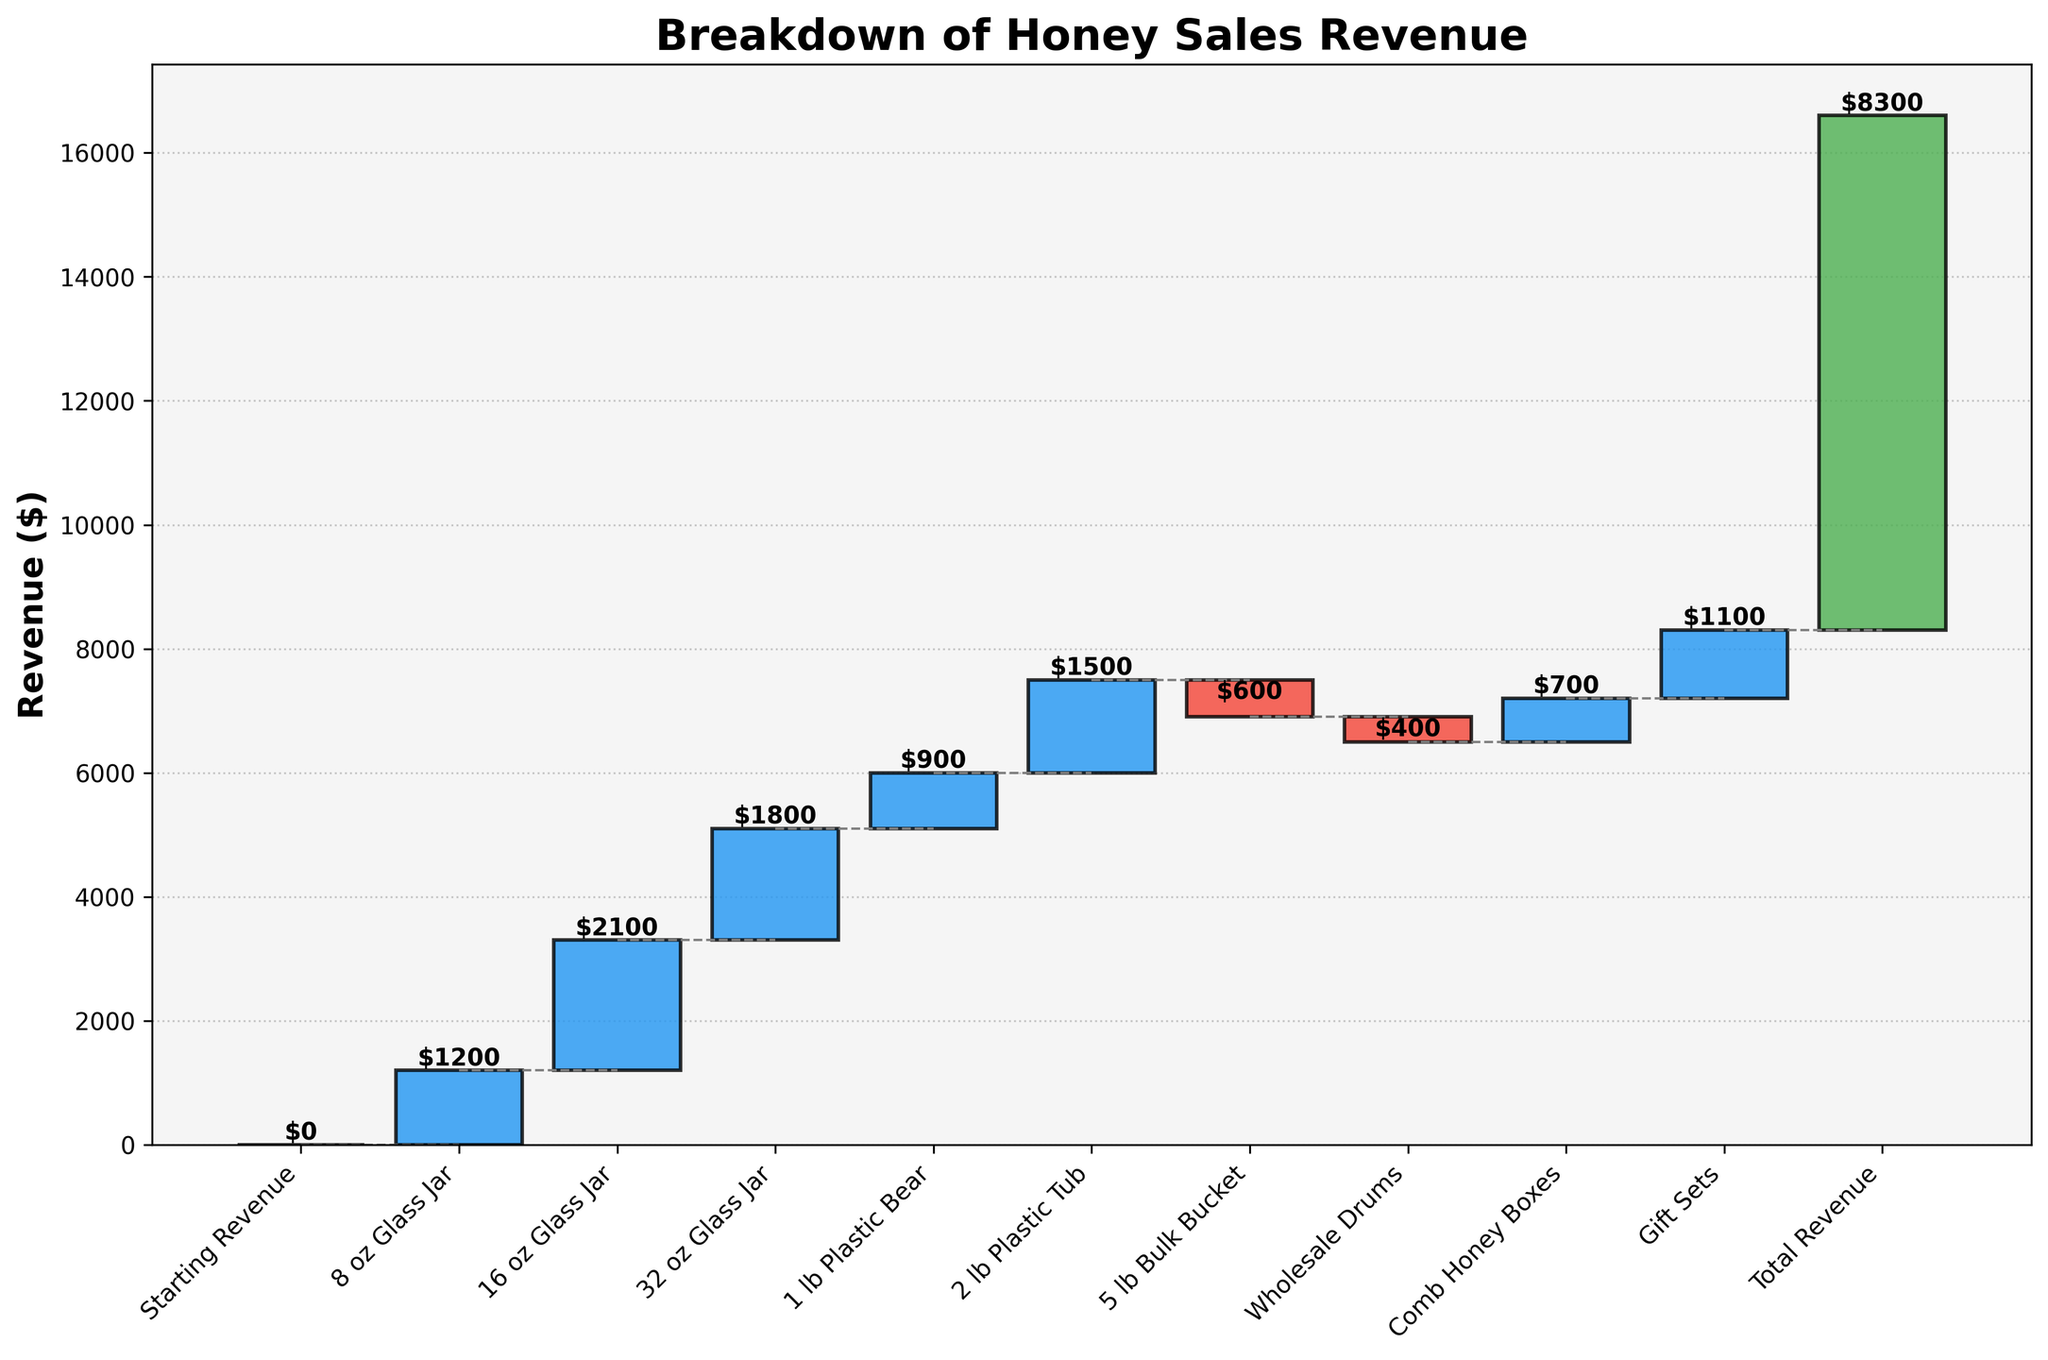what's the title of the figure? The title of the figure can be found at the top of the chart. It is usually in bold for emphasis.
Answer: Breakdown of Honey Sales Revenue what is the total revenue? The total revenue is indicated at the end of the waterfall chart, often labeled as "Total Revenue".
Answer: $8300 what is the revenue for 8 oz Glass Jar? Scan through the bars and their labels to find the one that corresponds to "8 oz Glass Jar"; the value should be marked near the top of the bar.
Answer: $1200 which category has the highest revenue increase? Compare the vertical lengths of all positive bars: the one with the longest bar indicates the highest revenue increase.
Answer: 16 oz Glass Jar which categories contribute to a decrease in revenue? Look for bars that extend downward; their labels show which categories they belong to.
Answer: 5 lb Bulk Bucket, Wholesale Drums how much more revenue does the 16 oz Glass Jar generate compared to 8 oz Glass Jar? Find the individual revenues for both 16 oz and 8 oz Glass Jars and subtract the smaller from the larger: $2100 - $1200.
Answer: $900 what is the combined revenue of all Glass Jar categories? Sum up the values corresponding to 8 oz, 16 oz, and 32 oz Glass Jars: $1200 + $2100 + $1800.
Answer: $5100 is the revenue from Wholesale Drums positive or negative? Check the direction of the bar; if it extends downward, it's negative.
Answer: Negative how does the revenue from Gift Sets compare to Comb Honey Boxes? Compare the labeled values of both Gift Sets and Comb Honey Boxes to see which is larger and by how much: $1100 - $700.
Answer: Gift Sets generate $400 more list all categories with a positive revenue. Identify all the bars extending upward and list their corresponding labels.
Answer: 8 oz Glass Jar, 16 oz Glass Jar, 32 oz Glass Jar, 1 lb Plastic Bear, 2 lb Plastic Tub, Comb Honey Boxes, Gift Sets 